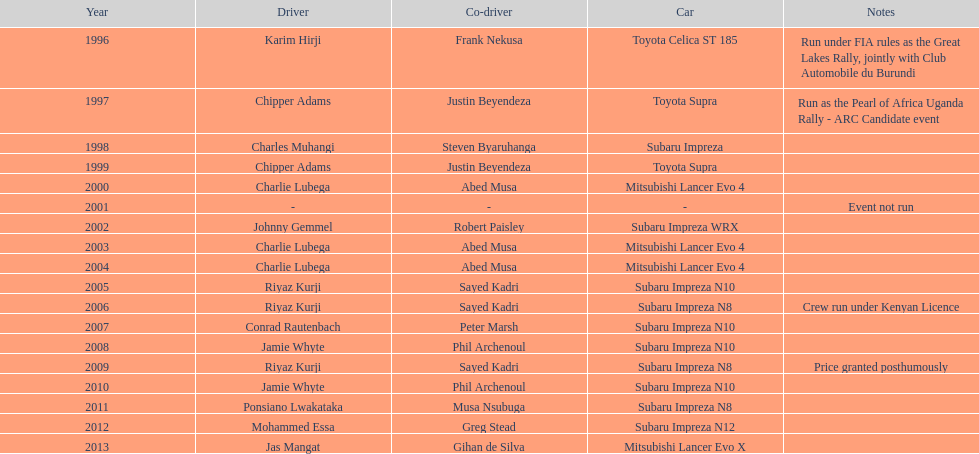What is the total number of times that the winning driver was driving a toyota supra? 2. 